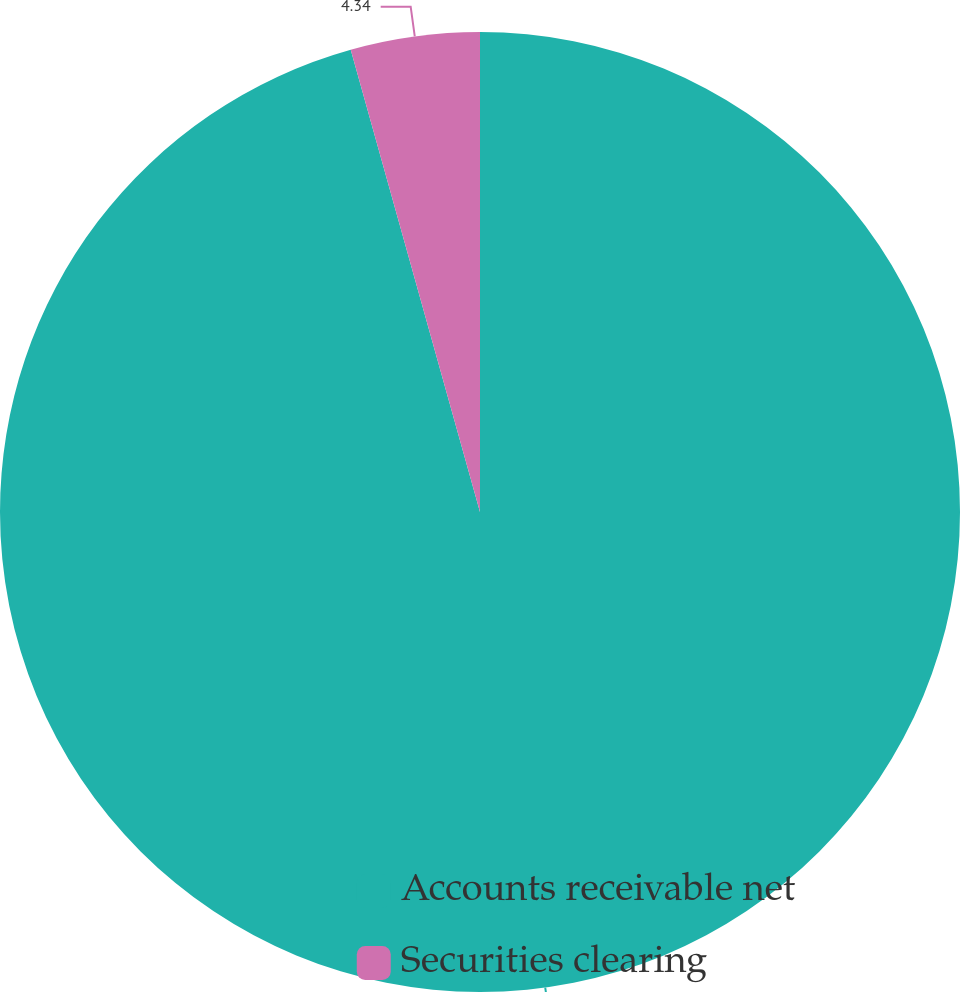<chart> <loc_0><loc_0><loc_500><loc_500><pie_chart><fcel>Accounts receivable net<fcel>Securities clearing<nl><fcel>95.66%<fcel>4.34%<nl></chart> 